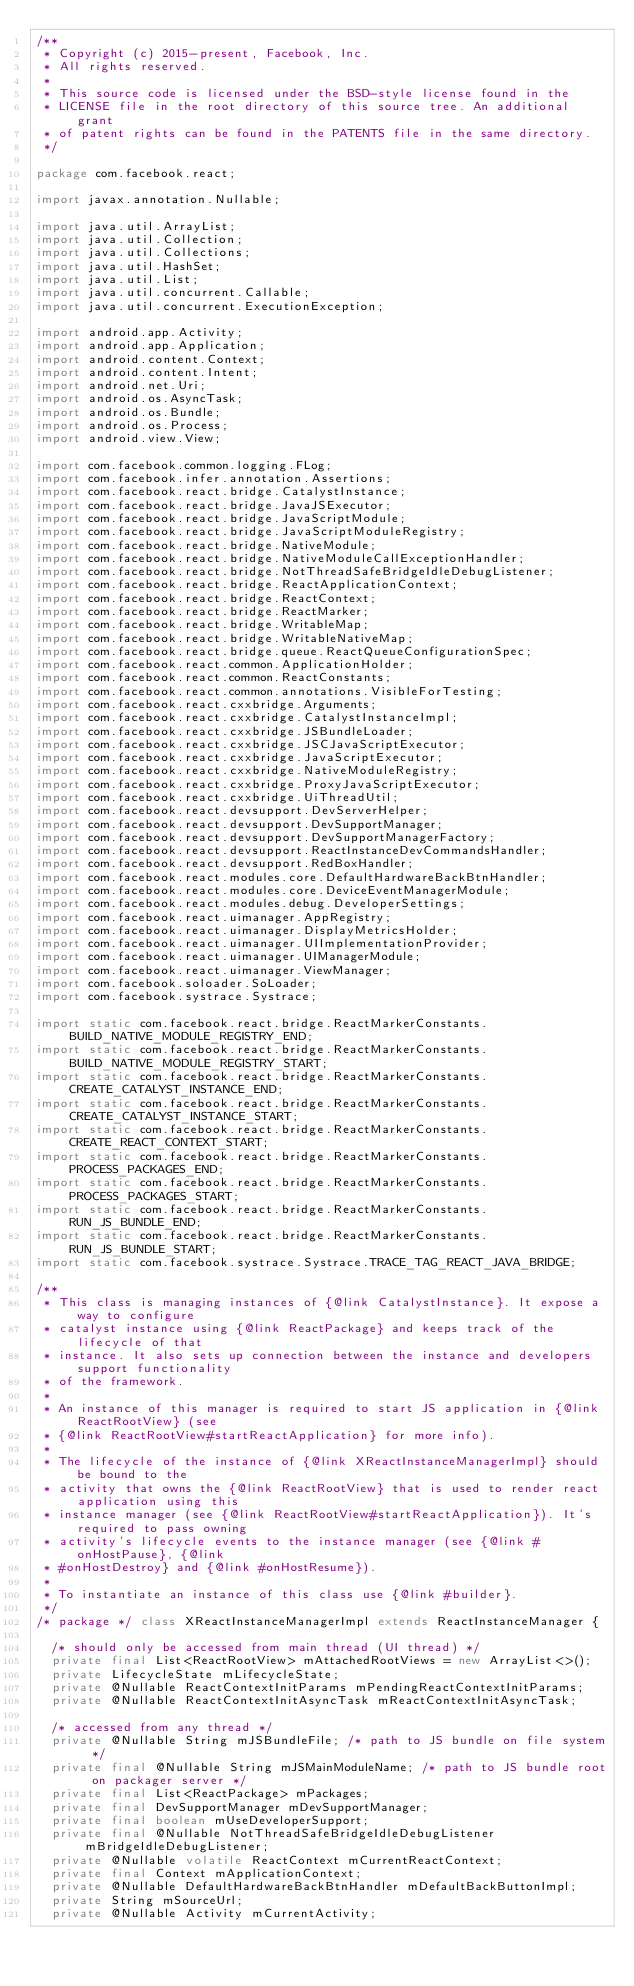<code> <loc_0><loc_0><loc_500><loc_500><_Java_>/**
 * Copyright (c) 2015-present, Facebook, Inc.
 * All rights reserved.
 *
 * This source code is licensed under the BSD-style license found in the
 * LICENSE file in the root directory of this source tree. An additional grant
 * of patent rights can be found in the PATENTS file in the same directory.
 */

package com.facebook.react;

import javax.annotation.Nullable;

import java.util.ArrayList;
import java.util.Collection;
import java.util.Collections;
import java.util.HashSet;
import java.util.List;
import java.util.concurrent.Callable;
import java.util.concurrent.ExecutionException;

import android.app.Activity;
import android.app.Application;
import android.content.Context;
import android.content.Intent;
import android.net.Uri;
import android.os.AsyncTask;
import android.os.Bundle;
import android.os.Process;
import android.view.View;

import com.facebook.common.logging.FLog;
import com.facebook.infer.annotation.Assertions;
import com.facebook.react.bridge.CatalystInstance;
import com.facebook.react.bridge.JavaJSExecutor;
import com.facebook.react.bridge.JavaScriptModule;
import com.facebook.react.bridge.JavaScriptModuleRegistry;
import com.facebook.react.bridge.NativeModule;
import com.facebook.react.bridge.NativeModuleCallExceptionHandler;
import com.facebook.react.bridge.NotThreadSafeBridgeIdleDebugListener;
import com.facebook.react.bridge.ReactApplicationContext;
import com.facebook.react.bridge.ReactContext;
import com.facebook.react.bridge.ReactMarker;
import com.facebook.react.bridge.WritableMap;
import com.facebook.react.bridge.WritableNativeMap;
import com.facebook.react.bridge.queue.ReactQueueConfigurationSpec;
import com.facebook.react.common.ApplicationHolder;
import com.facebook.react.common.ReactConstants;
import com.facebook.react.common.annotations.VisibleForTesting;
import com.facebook.react.cxxbridge.Arguments;
import com.facebook.react.cxxbridge.CatalystInstanceImpl;
import com.facebook.react.cxxbridge.JSBundleLoader;
import com.facebook.react.cxxbridge.JSCJavaScriptExecutor;
import com.facebook.react.cxxbridge.JavaScriptExecutor;
import com.facebook.react.cxxbridge.NativeModuleRegistry;
import com.facebook.react.cxxbridge.ProxyJavaScriptExecutor;
import com.facebook.react.cxxbridge.UiThreadUtil;
import com.facebook.react.devsupport.DevServerHelper;
import com.facebook.react.devsupport.DevSupportManager;
import com.facebook.react.devsupport.DevSupportManagerFactory;
import com.facebook.react.devsupport.ReactInstanceDevCommandsHandler;
import com.facebook.react.devsupport.RedBoxHandler;
import com.facebook.react.modules.core.DefaultHardwareBackBtnHandler;
import com.facebook.react.modules.core.DeviceEventManagerModule;
import com.facebook.react.modules.debug.DeveloperSettings;
import com.facebook.react.uimanager.AppRegistry;
import com.facebook.react.uimanager.DisplayMetricsHolder;
import com.facebook.react.uimanager.UIImplementationProvider;
import com.facebook.react.uimanager.UIManagerModule;
import com.facebook.react.uimanager.ViewManager;
import com.facebook.soloader.SoLoader;
import com.facebook.systrace.Systrace;

import static com.facebook.react.bridge.ReactMarkerConstants.BUILD_NATIVE_MODULE_REGISTRY_END;
import static com.facebook.react.bridge.ReactMarkerConstants.BUILD_NATIVE_MODULE_REGISTRY_START;
import static com.facebook.react.bridge.ReactMarkerConstants.CREATE_CATALYST_INSTANCE_END;
import static com.facebook.react.bridge.ReactMarkerConstants.CREATE_CATALYST_INSTANCE_START;
import static com.facebook.react.bridge.ReactMarkerConstants.CREATE_REACT_CONTEXT_START;
import static com.facebook.react.bridge.ReactMarkerConstants.PROCESS_PACKAGES_END;
import static com.facebook.react.bridge.ReactMarkerConstants.PROCESS_PACKAGES_START;
import static com.facebook.react.bridge.ReactMarkerConstants.RUN_JS_BUNDLE_END;
import static com.facebook.react.bridge.ReactMarkerConstants.RUN_JS_BUNDLE_START;
import static com.facebook.systrace.Systrace.TRACE_TAG_REACT_JAVA_BRIDGE;

/**
 * This class is managing instances of {@link CatalystInstance}. It expose a way to configure
 * catalyst instance using {@link ReactPackage} and keeps track of the lifecycle of that
 * instance. It also sets up connection between the instance and developers support functionality
 * of the framework.
 *
 * An instance of this manager is required to start JS application in {@link ReactRootView} (see
 * {@link ReactRootView#startReactApplication} for more info).
 *
 * The lifecycle of the instance of {@link XReactInstanceManagerImpl} should be bound to the
 * activity that owns the {@link ReactRootView} that is used to render react application using this
 * instance manager (see {@link ReactRootView#startReactApplication}). It's required to pass owning
 * activity's lifecycle events to the instance manager (see {@link #onHostPause}, {@link
 * #onHostDestroy} and {@link #onHostResume}).
 *
 * To instantiate an instance of this class use {@link #builder}.
 */
/* package */ class XReactInstanceManagerImpl extends ReactInstanceManager {

  /* should only be accessed from main thread (UI thread) */
  private final List<ReactRootView> mAttachedRootViews = new ArrayList<>();
  private LifecycleState mLifecycleState;
  private @Nullable ReactContextInitParams mPendingReactContextInitParams;
  private @Nullable ReactContextInitAsyncTask mReactContextInitAsyncTask;

  /* accessed from any thread */
  private @Nullable String mJSBundleFile; /* path to JS bundle on file system */
  private final @Nullable String mJSMainModuleName; /* path to JS bundle root on packager server */
  private final List<ReactPackage> mPackages;
  private final DevSupportManager mDevSupportManager;
  private final boolean mUseDeveloperSupport;
  private final @Nullable NotThreadSafeBridgeIdleDebugListener mBridgeIdleDebugListener;
  private @Nullable volatile ReactContext mCurrentReactContext;
  private final Context mApplicationContext;
  private @Nullable DefaultHardwareBackBtnHandler mDefaultBackButtonImpl;
  private String mSourceUrl;
  private @Nullable Activity mCurrentActivity;</code> 